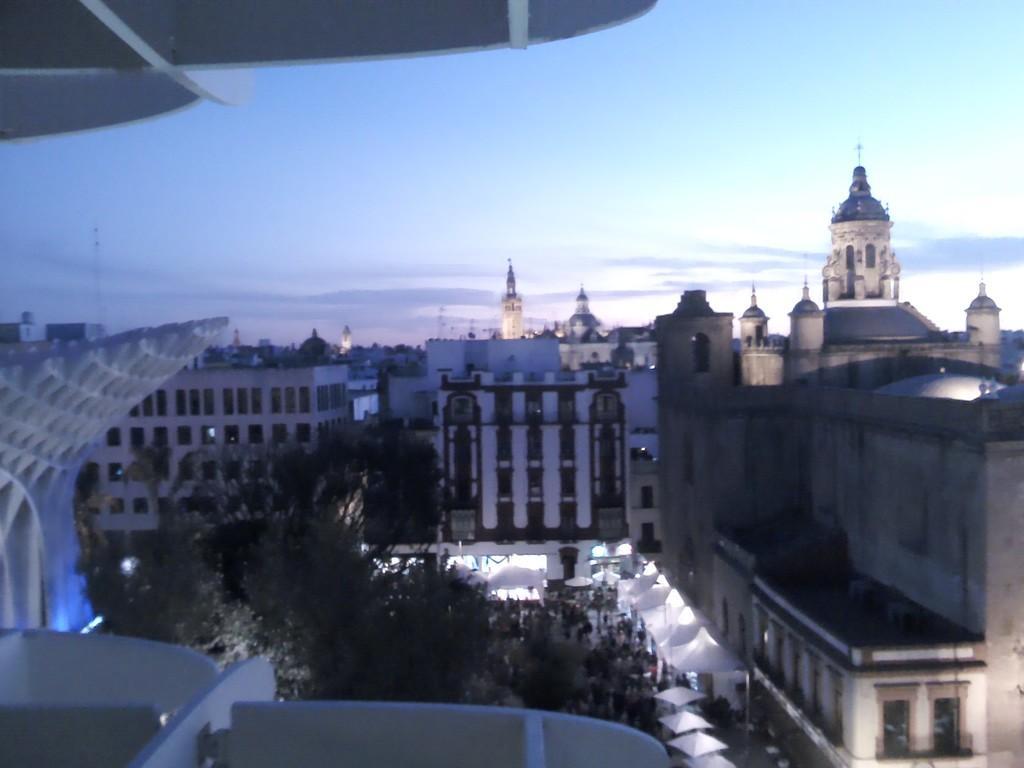Can you describe this image briefly? In this image I can see in the middle there are trees and there are buildings and at the top it is the cloudy sky. 